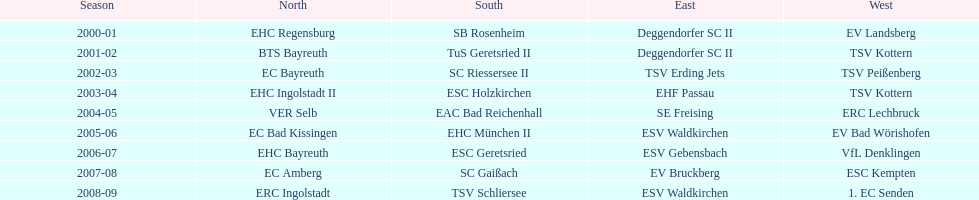Which teams were the champions of the bavarian ice hockey leagues from 2000 to 2009? EHC Regensburg, SB Rosenheim, Deggendorfer SC II, EV Landsberg, BTS Bayreuth, TuS Geretsried II, TSV Kottern, EC Bayreuth, SC Riessersee II, TSV Erding Jets, TSV Peißenberg, EHC Ingolstadt II, ESC Holzkirchen, EHF Passau, TSV Kottern, VER Selb, EAC Bad Reichenhall, SE Freising, ERC Lechbruck, EC Bad Kissingen, EHC München II, ESV Waldkirchen, EV Bad Wörishofen, EHC Bayreuth, ESC Geretsried, ESV Gebensbach, VfL Denklingen, EC Amberg, SC Gaißach, EV Bruckberg, ESC Kempten, ERC Ingolstadt, TSV Schliersee, ESV Waldkirchen, 1. EC Senden. Which of these victorious teams also took the title in the north? EHC Regensburg, BTS Bayreuth, EC Bayreuth, EHC Ingolstadt II, VER Selb, EC Bad Kissingen, EHC Bayreuth, EC Amberg, ERC Ingolstadt. Furthermore, which of the northern winners succeeded in the 2000/2001 season? EHC Regensburg. 